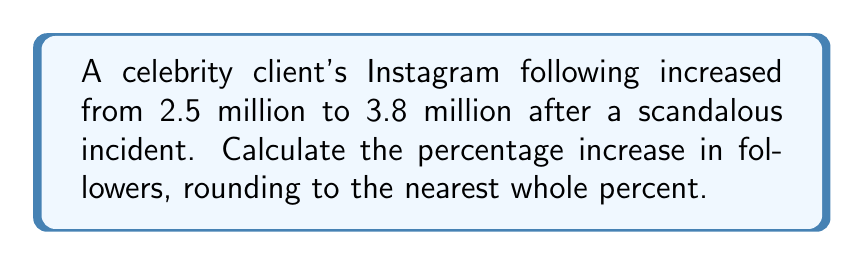Can you solve this math problem? To calculate the percentage increase, we'll follow these steps:

1. Calculate the absolute increase in followers:
   $\text{Increase} = \text{New followers} - \text{Original followers}$
   $\text{Increase} = 3.8 \text{ million} - 2.5 \text{ million} = 1.3 \text{ million}$

2. Use the percentage increase formula:
   $\text{Percentage increase} = \frac{\text{Increase}}{\text{Original value}} \times 100\%$

3. Plug in the values:
   $$\text{Percentage increase} = \frac{1.3 \text{ million}}{2.5 \text{ million}} \times 100\%$$

4. Simplify and calculate:
   $$\text{Percentage increase} = \frac{1.3}{2.5} \times 100\% = 0.52 \times 100\% = 52\%$$

5. Round to the nearest whole percent:
   The result is already a whole number, so no rounding is necessary.
Answer: 52% 